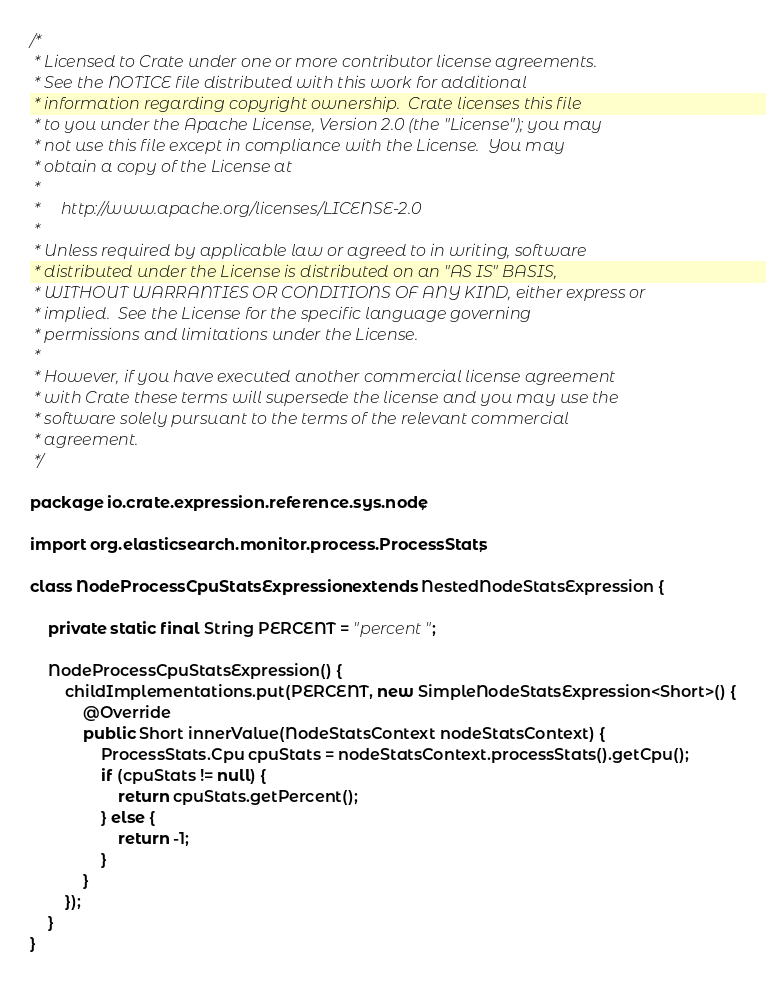Convert code to text. <code><loc_0><loc_0><loc_500><loc_500><_Java_>/*
 * Licensed to Crate under one or more contributor license agreements.
 * See the NOTICE file distributed with this work for additional
 * information regarding copyright ownership.  Crate licenses this file
 * to you under the Apache License, Version 2.0 (the "License"); you may
 * not use this file except in compliance with the License.  You may
 * obtain a copy of the License at
 *
 *     http://www.apache.org/licenses/LICENSE-2.0
 *
 * Unless required by applicable law or agreed to in writing, software
 * distributed under the License is distributed on an "AS IS" BASIS,
 * WITHOUT WARRANTIES OR CONDITIONS OF ANY KIND, either express or
 * implied.  See the License for the specific language governing
 * permissions and limitations under the License.
 *
 * However, if you have executed another commercial license agreement
 * with Crate these terms will supersede the license and you may use the
 * software solely pursuant to the terms of the relevant commercial
 * agreement.
 */

package io.crate.expression.reference.sys.node;

import org.elasticsearch.monitor.process.ProcessStats;

class NodeProcessCpuStatsExpression extends NestedNodeStatsExpression {

    private static final String PERCENT = "percent";

    NodeProcessCpuStatsExpression() {
        childImplementations.put(PERCENT, new SimpleNodeStatsExpression<Short>() {
            @Override
            public Short innerValue(NodeStatsContext nodeStatsContext) {
                ProcessStats.Cpu cpuStats = nodeStatsContext.processStats().getCpu();
                if (cpuStats != null) {
                    return cpuStats.getPercent();
                } else {
                    return -1;
                }
            }
        });
    }
}
</code> 